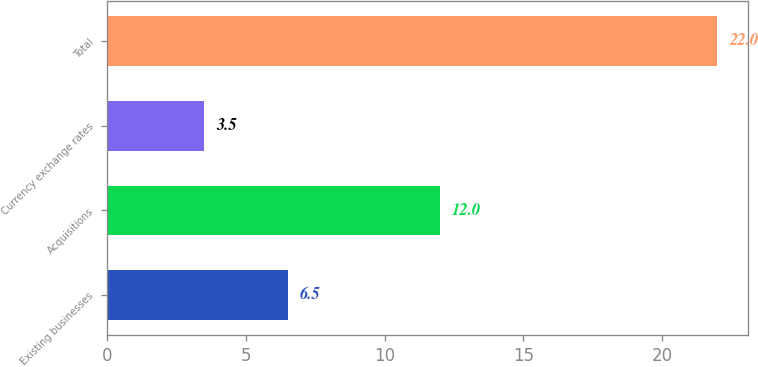<chart> <loc_0><loc_0><loc_500><loc_500><bar_chart><fcel>Existing businesses<fcel>Acquisitions<fcel>Currency exchange rates<fcel>Total<nl><fcel>6.5<fcel>12<fcel>3.5<fcel>22<nl></chart> 